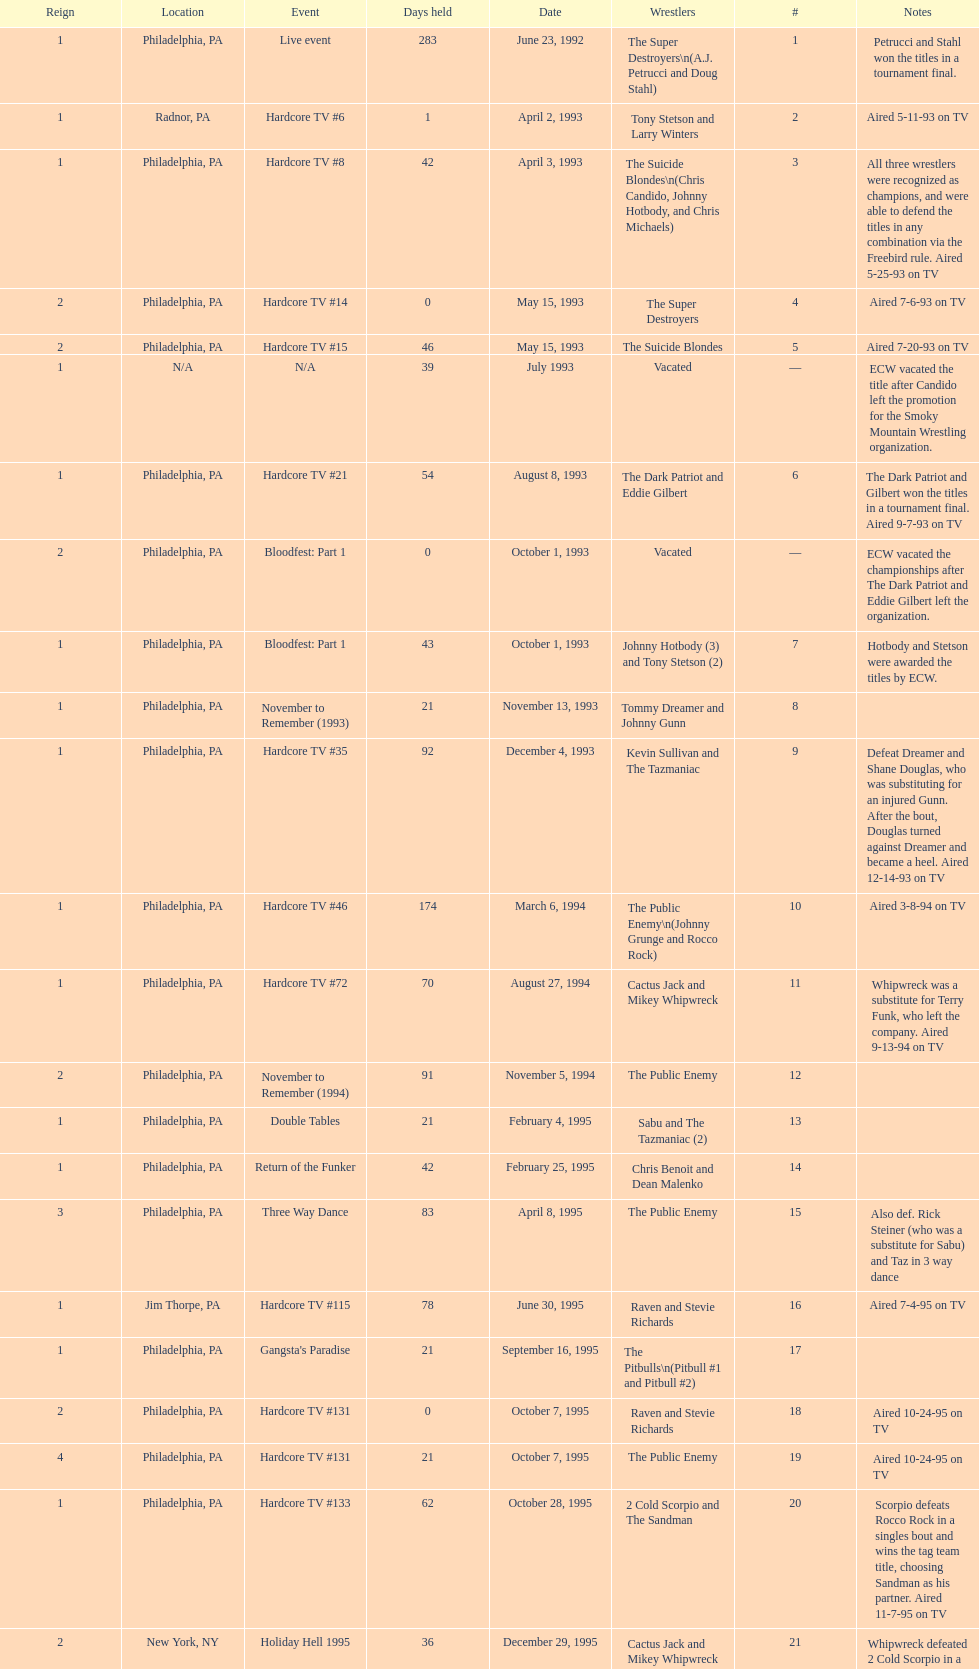What event comes before hardcore tv #14? Hardcore TV #8. 